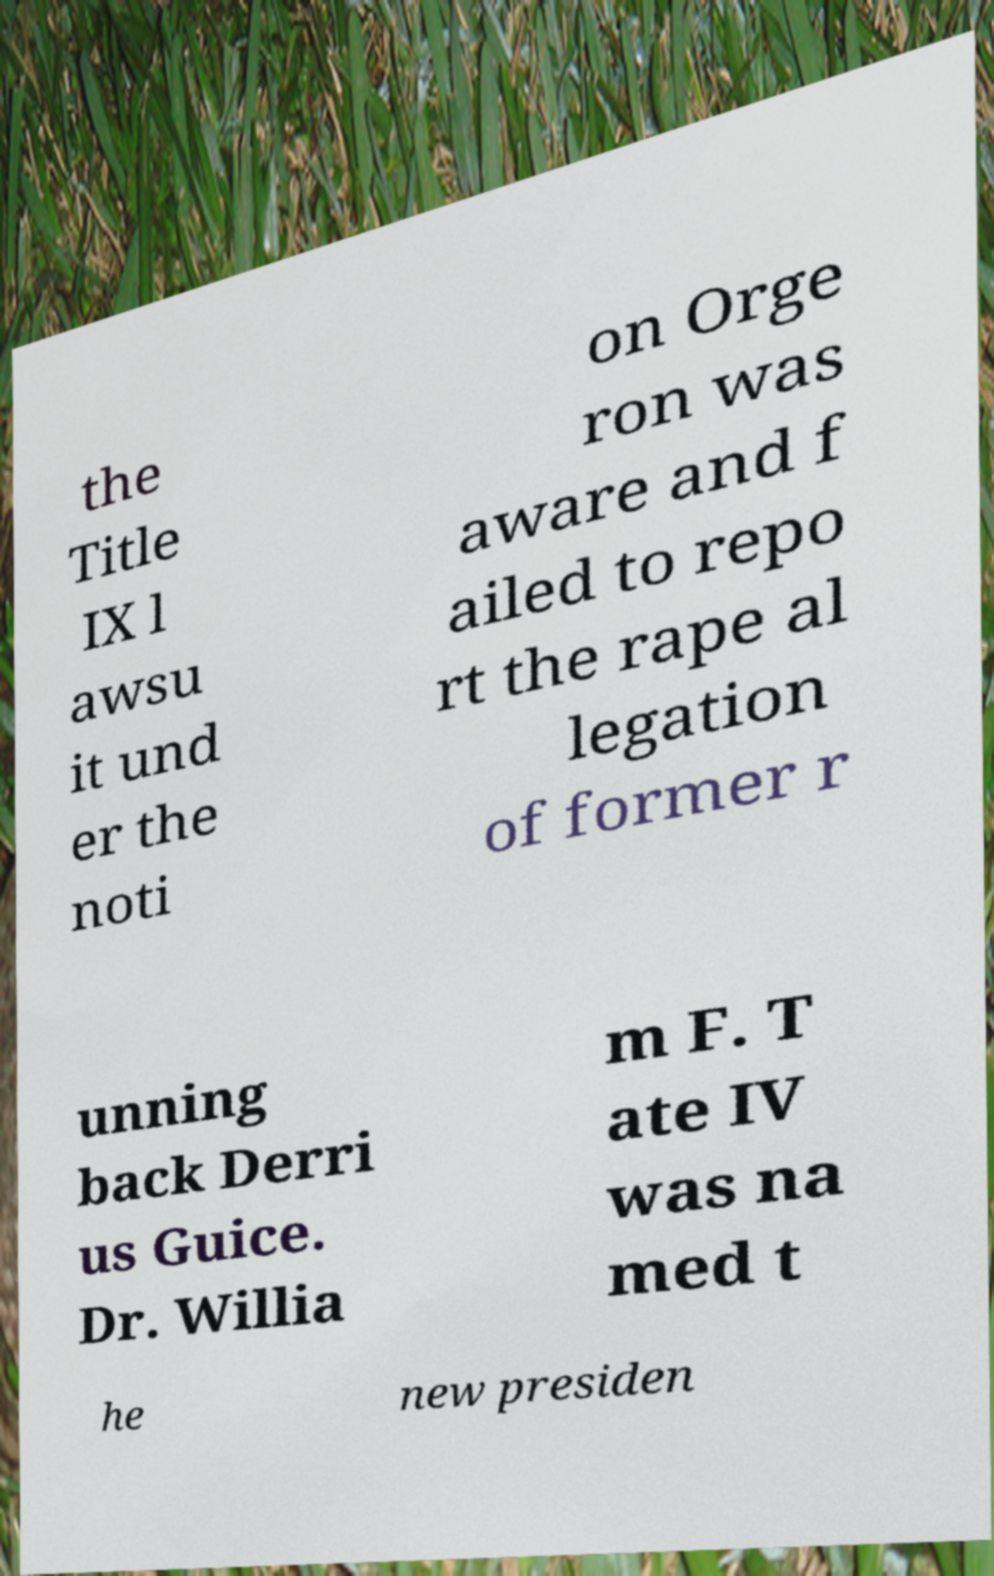Can you accurately transcribe the text from the provided image for me? the Title IX l awsu it und er the noti on Orge ron was aware and f ailed to repo rt the rape al legation of former r unning back Derri us Guice. Dr. Willia m F. T ate IV was na med t he new presiden 